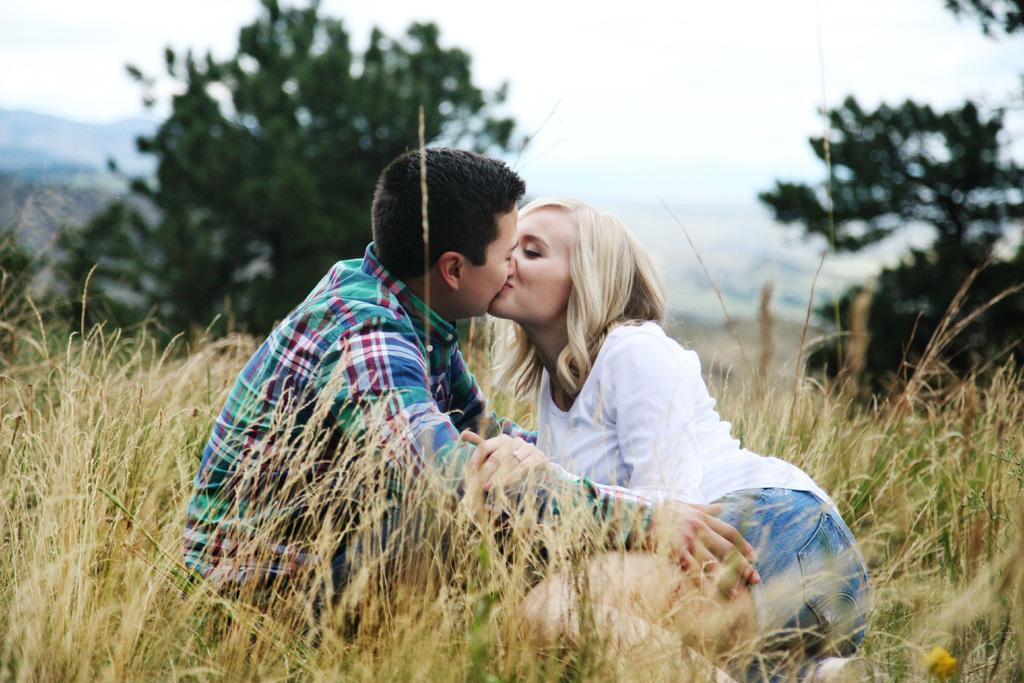How many people are in the image? There are two people in the image. What are the two people doing in the image? The two people are kissing. What can be seen in the background of the image? There is a sky, clouds, trees, plants, and grass visible in the background of the image. How many waves can be seen in the image? There are no waves present in the image. What color is the eye of the person on the left in the image? There is no information about the color of anyone's eyes in the image, as it focuses on the two people kissing and the background. 